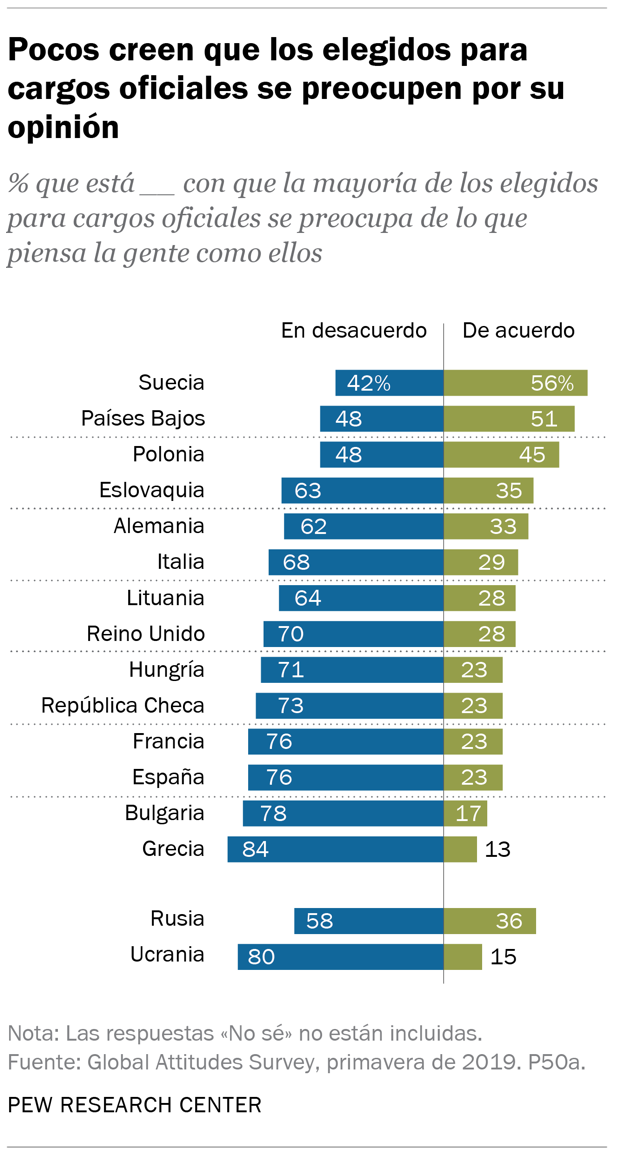Point out several critical features in this image. The ratio of green bar occurrences with values 28 and 23 is 0.043055556..., which means that there are 0.043055556... green bars with these specific values out of every 100 total green bars. The color of the bar is green, and its value in the Suecia category is 56%. In other words, the answer to the question is yes. 